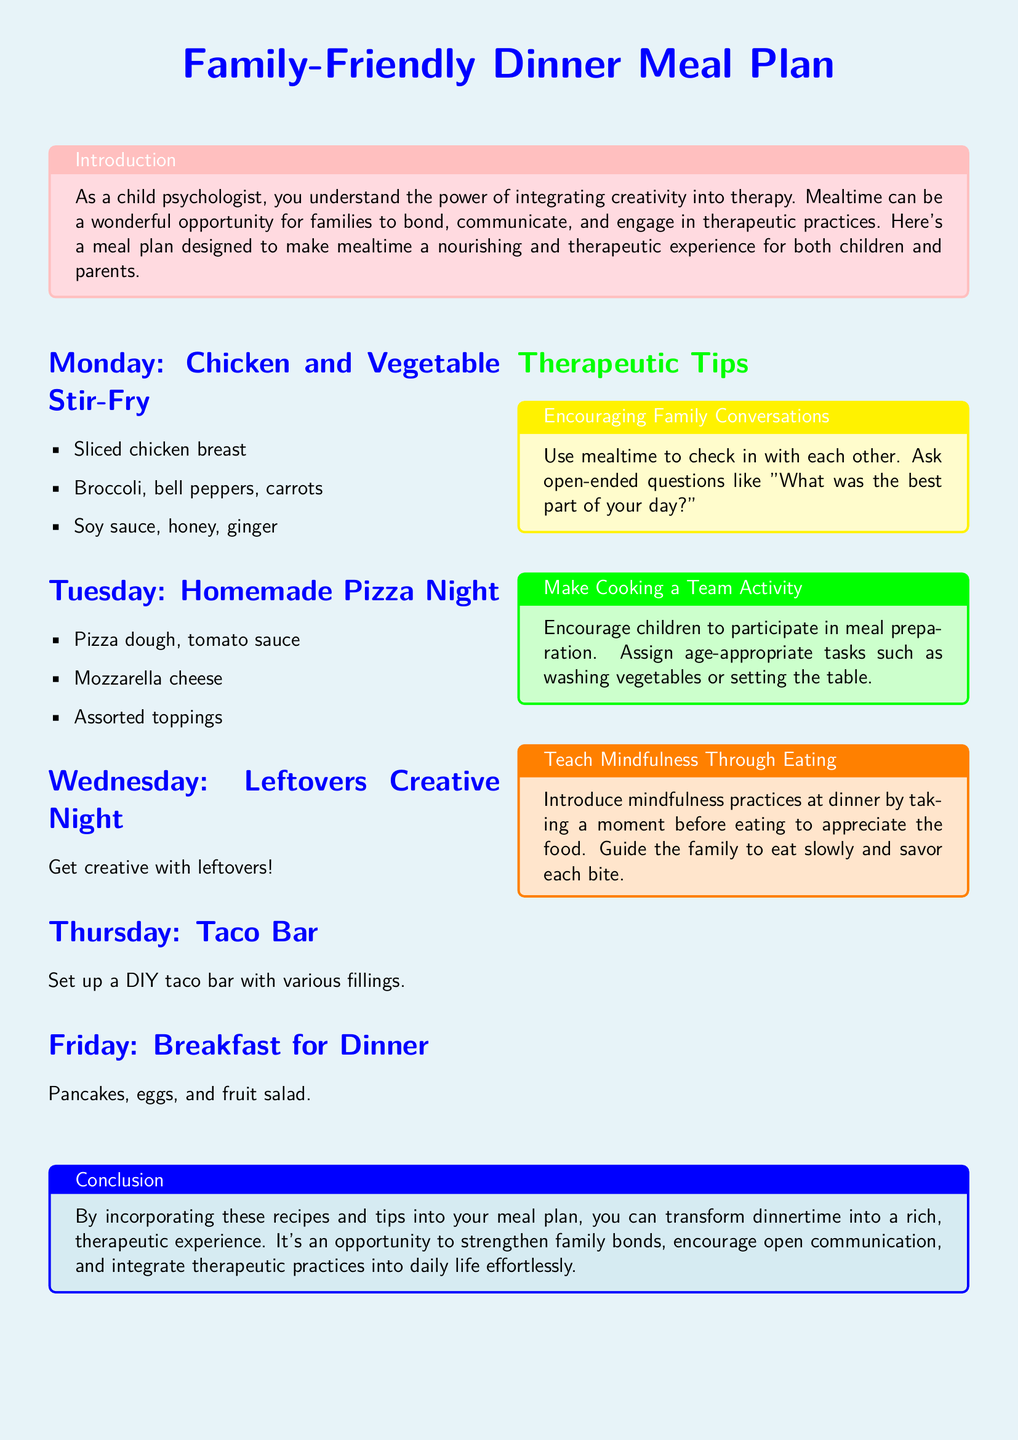What is the meal for Monday? The document states that Monday's meal is Chicken and Vegetable Stir-Fry.
Answer: Chicken and Vegetable Stir-Fry What type of night is Wednesday? It is labeled as Leftovers Creative Night in the document.
Answer: Leftovers Creative Night What is one of the ingredients for Tuesday's meal? The document mentions pizza dough as one of the ingredients for Tuesday's meal.
Answer: Pizza dough How many sections are in the therapeutic tips? There are three sections highlighted for therapeutic tips in the document.
Answer: Three What is one way to encourage family communication at mealtime? The document suggests asking open-ended questions like "What was the best part of your day?"
Answer: Open-ended questions On which day does the document suggest having a taco bar? The meal plan indicates that a taco bar is suggested for Thursday.
Answer: Thursday What practice should families introduce before eating? The document encourages families to take a moment to appreciate the food before eating.
Answer: Appreciate the food What is the primary theme of this meal plan? The main theme of the meal plan is integrating creativity into mealtime for bonding and therapeutic purposes.
Answer: Creativity in mealtime What kind of food is suggested for Friday's dinner? The document proposes pancakes, eggs, and fruit salad for Friday's dinner.
Answer: Pancakes, eggs, and fruit salad 